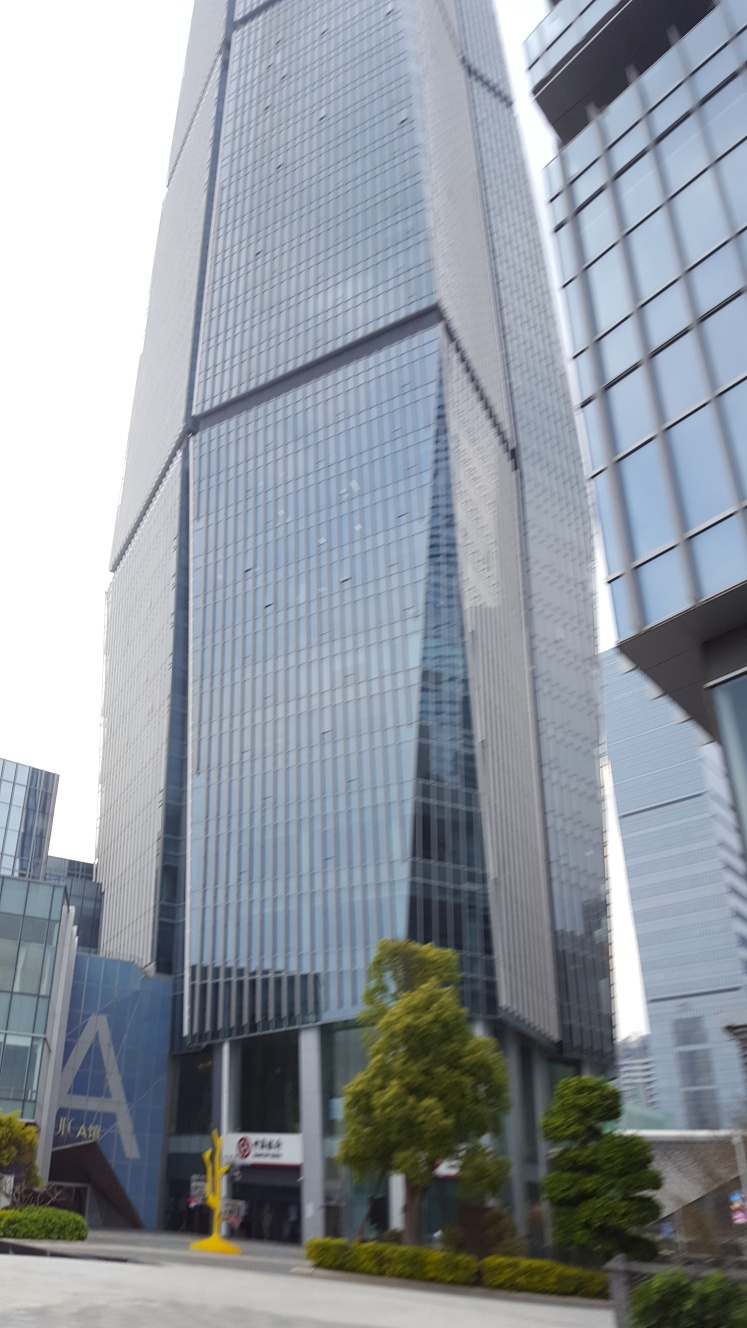What architectural styles are represented in the buildings of this image? The buildings in the image showcase modern architectural elements, with a focus on glass facades, steel structures, and a sleek, streamlined form that is typical of contemporary urban skyscrapers. The design emphasizes functionality and minimalism. 